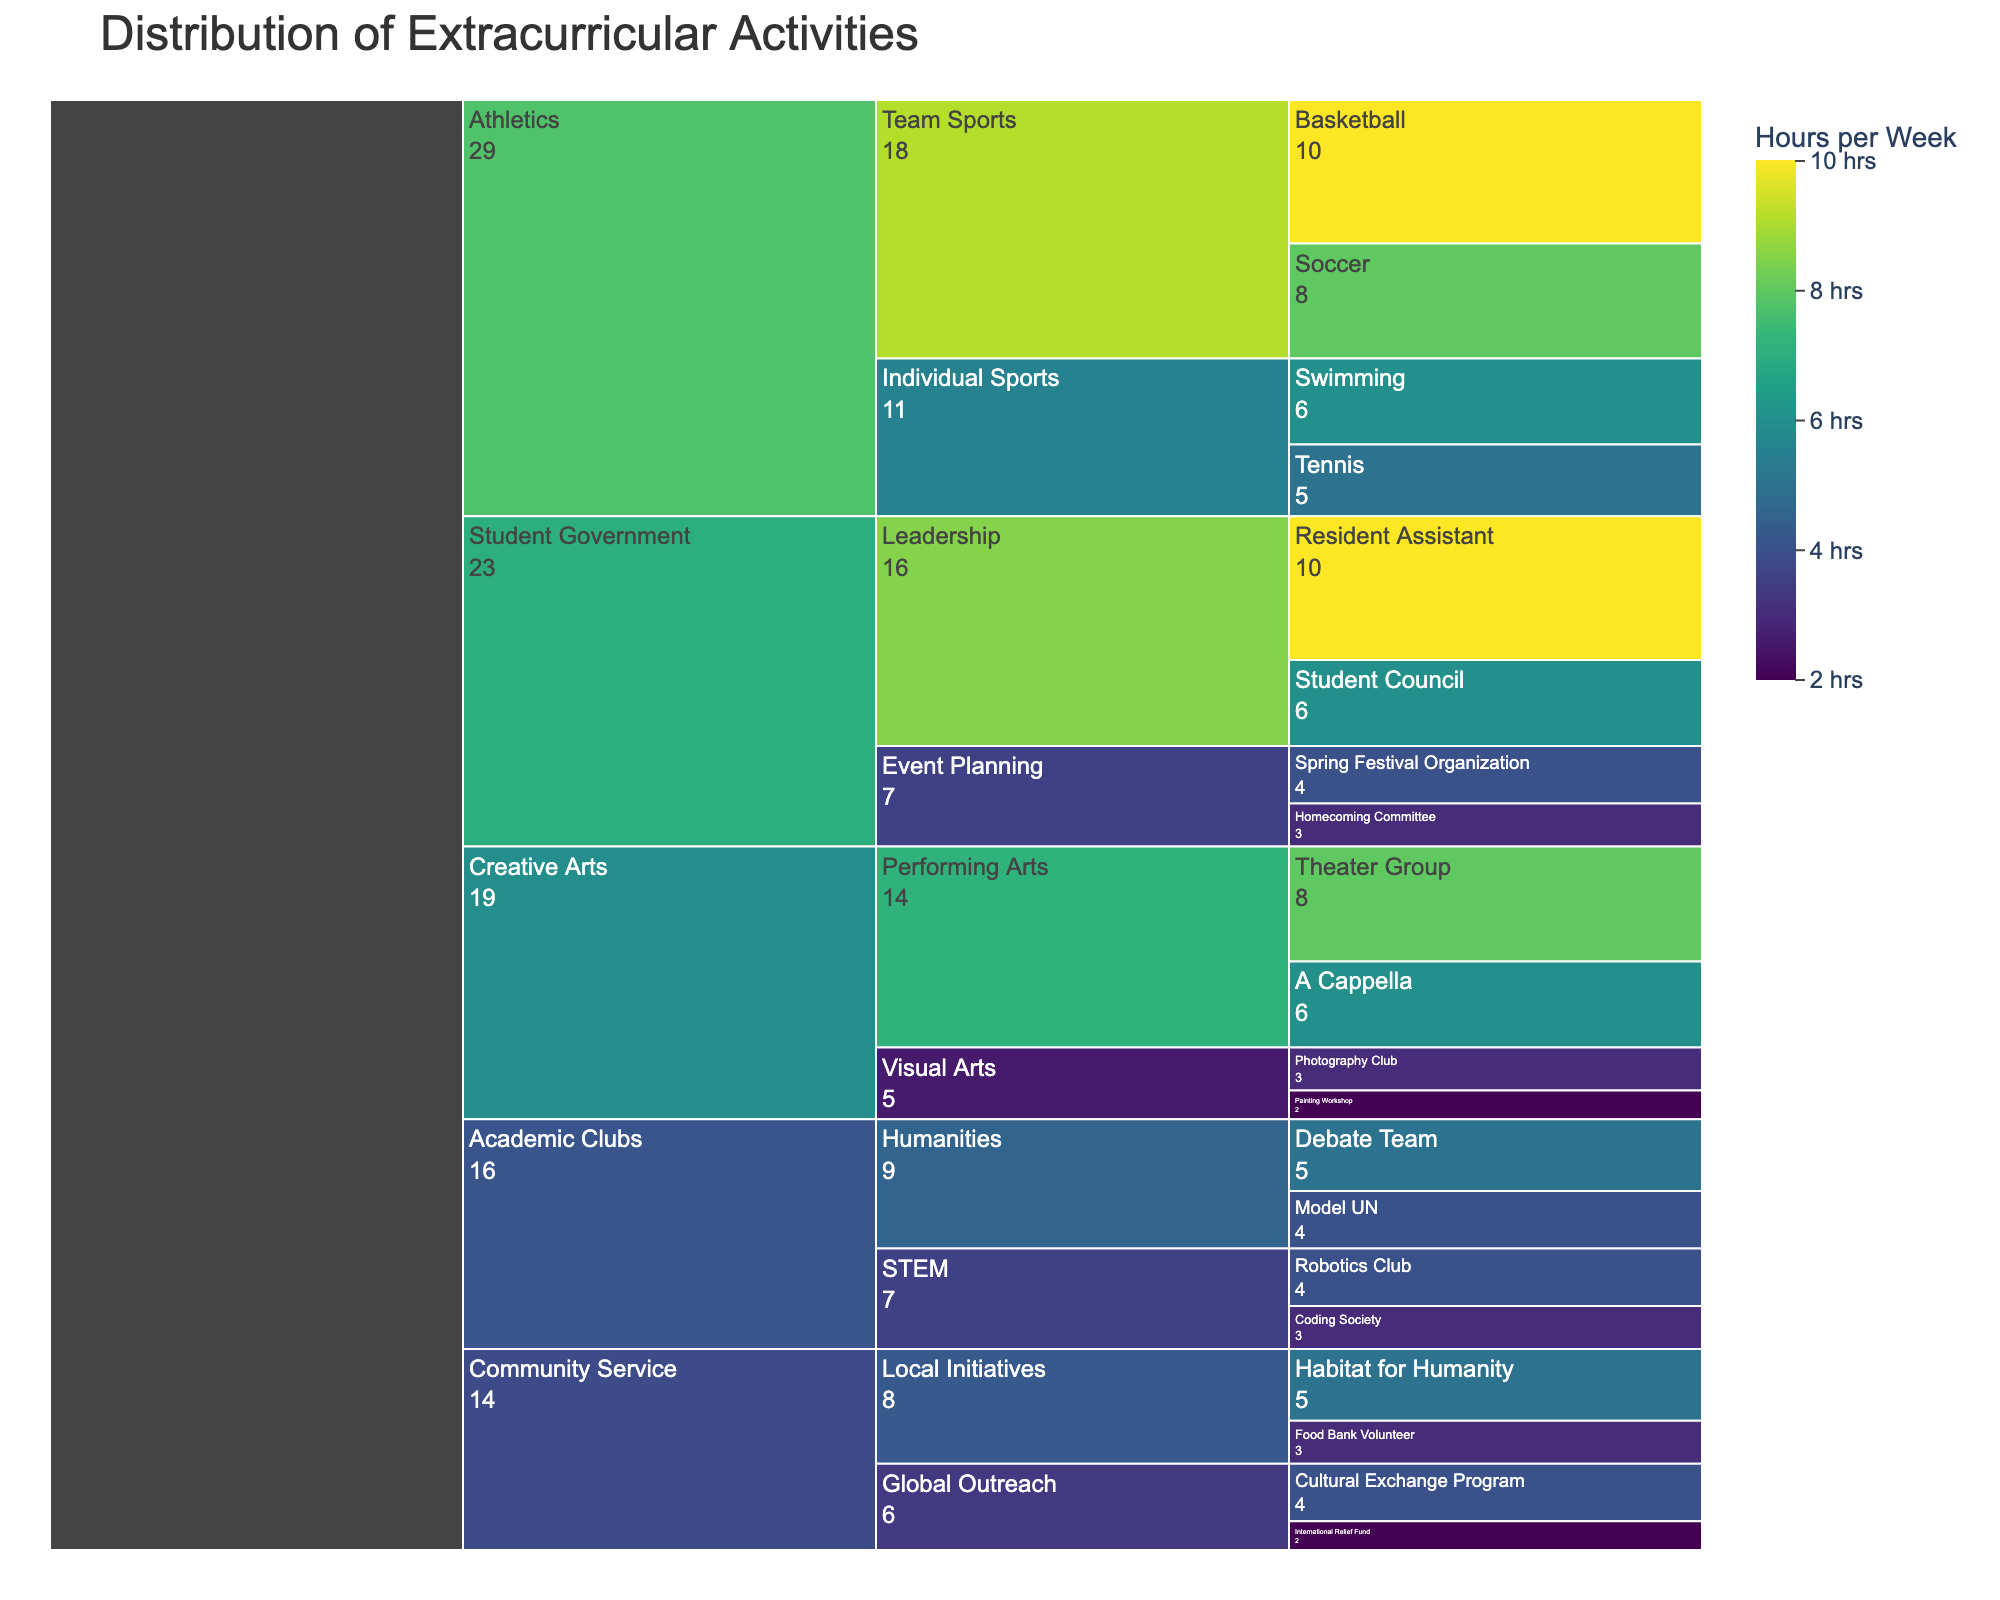What's the title of the figure? The title of the figure is displayed at the top of the icicle chart.
Answer: Distribution of Extracurricular Activities What's the highest number of hours per week committed to a single activity? The icicle chart showcases the hours per week in color intensity, and the hover template shows detailed values. By identifying the most intensely colored segment, we find the maximum value.
Answer: 10 hours Which subcategory within Athletics has the highest time commitment on average? From the icicle chart, find the subcategories under Athletics and calculate their average time commitments. Athletics has Team Sports (Basketball: 10, Soccer: 8, Average: 9) and Individual Sports (Swimming: 6, Tennis: 5, Average: 5.5). So, Team Sports has a higher average.
Answer: Team Sports Which activity in Creative Arts has the lowest time commitment per week? Locate the smallest value for activities within the Creative Arts category by referencing both Visual Arts and Performing Arts subcategories. The minimum value is found by checking each segment.
Answer: Painting Workshop (2 hours) Between STEM and Humanities subcategories in Academic Clubs, which has a higher total time commitment? Sum the time commitments for activities in the STEM (Robotics Club: 4, Coding Society: 3, Total: 7) and Humanities (Debate Team: 5, Model UN: 4, Total: 9) subcategories, and then compare the totals.
Answer: Humanities What's the total time spent per week on Community Service activities? Add up the weekly hours for all activities under Community Service. Local Initiatives (Habitat for Humanity: 5, Food Bank Volunteer: 3) and Global Outreach (International Relief Fund: 2, Cultural Exchange Program: 4) total to 5 + 3 + 2 + 4.
Answer: 14 hours Which category has the most varied range of time commitments across its activities? Evaluate the range (difference between highest and lowest values) for time commitments in each category. Compare ranges for Athletics, Academic Clubs, Creative Arts, Community Service, and Student Government. Student Government has the widest range (Resident Assistant: 10 to Event Planning: 3).
Answer: Student Government What is the average time commitment for activities in the Student Government category? Calculate the average time by summing the hours of Student Council (6), Resident Assistant (10), Homecoming Committee (3), and Spring Festival Organization (4), and then dividing by the number of activities. (6 + 10 + 3 + 4)/4.
Answer: 5.75 hours 